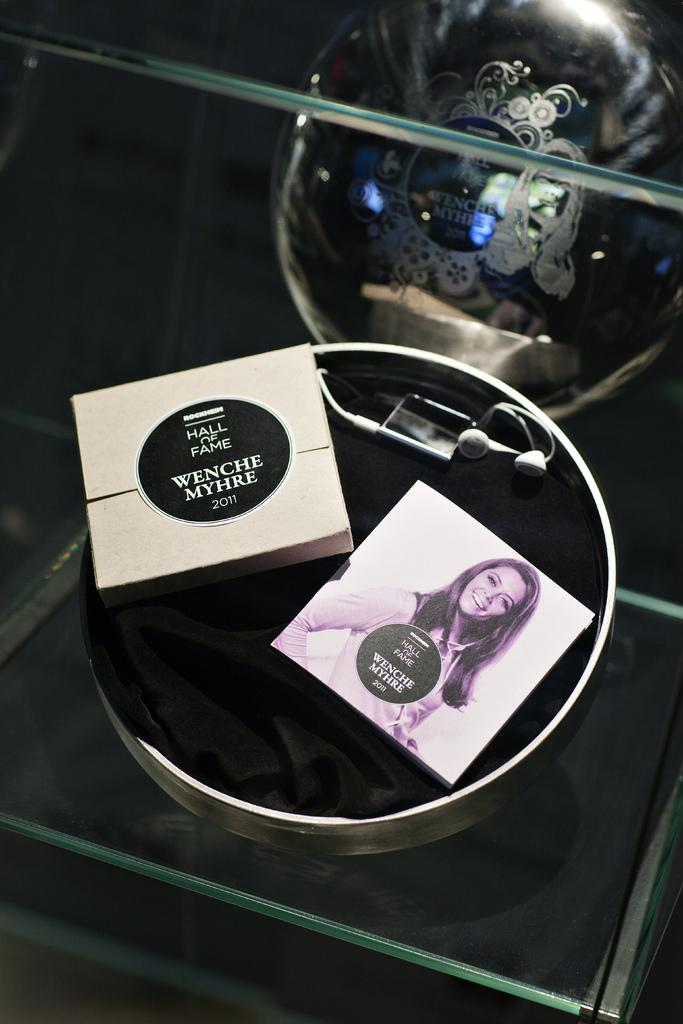What type of bowl is in the image? There is a steel bowl in the image. What is the surface beneath the steel bowl? The steel bowl is on a glass surface. What is inside the steel bowl? There is a black cloth, two boxes, and earphones in the bowl. Are there any other objects near the bowl? Yes, there is another box next to the bowl. What type of sign can be seen on the black cloth in the image? There is no sign present on the black cloth in the image. How many crows are sitting on the boxes in the image? There are no crows present in the image. 